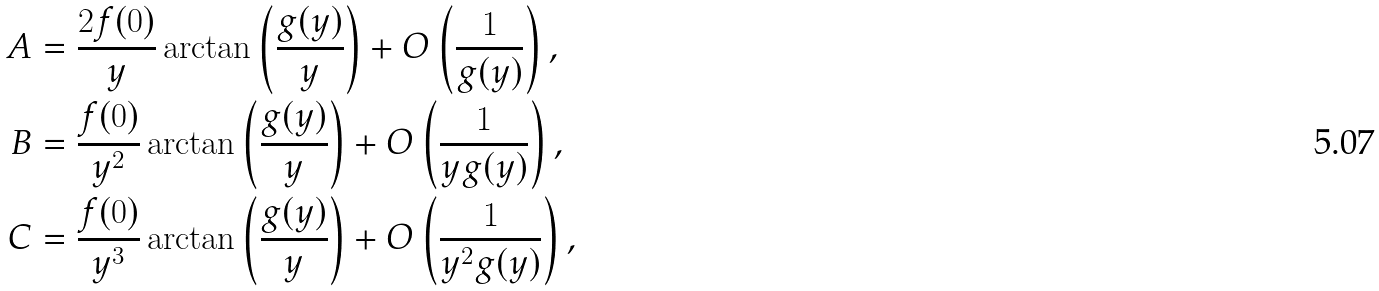<formula> <loc_0><loc_0><loc_500><loc_500>A & = \frac { 2 f ( 0 ) } { y } \arctan { \left ( \frac { g ( y ) } { y } \right ) } + O \left ( \frac { 1 } { g ( y ) } \right ) , \\ B & = \frac { f ( 0 ) } { y ^ { 2 } } \arctan { \left ( \frac { g ( y ) } { y } \right ) } + O \left ( \frac { 1 } { y g ( y ) } \right ) , \\ C & = \frac { f ( 0 ) } { y ^ { 3 } } \arctan { \left ( \frac { g ( y ) } { y } \right ) } + O \left ( \frac { 1 } { y ^ { 2 } g ( y ) } \right ) ,</formula> 